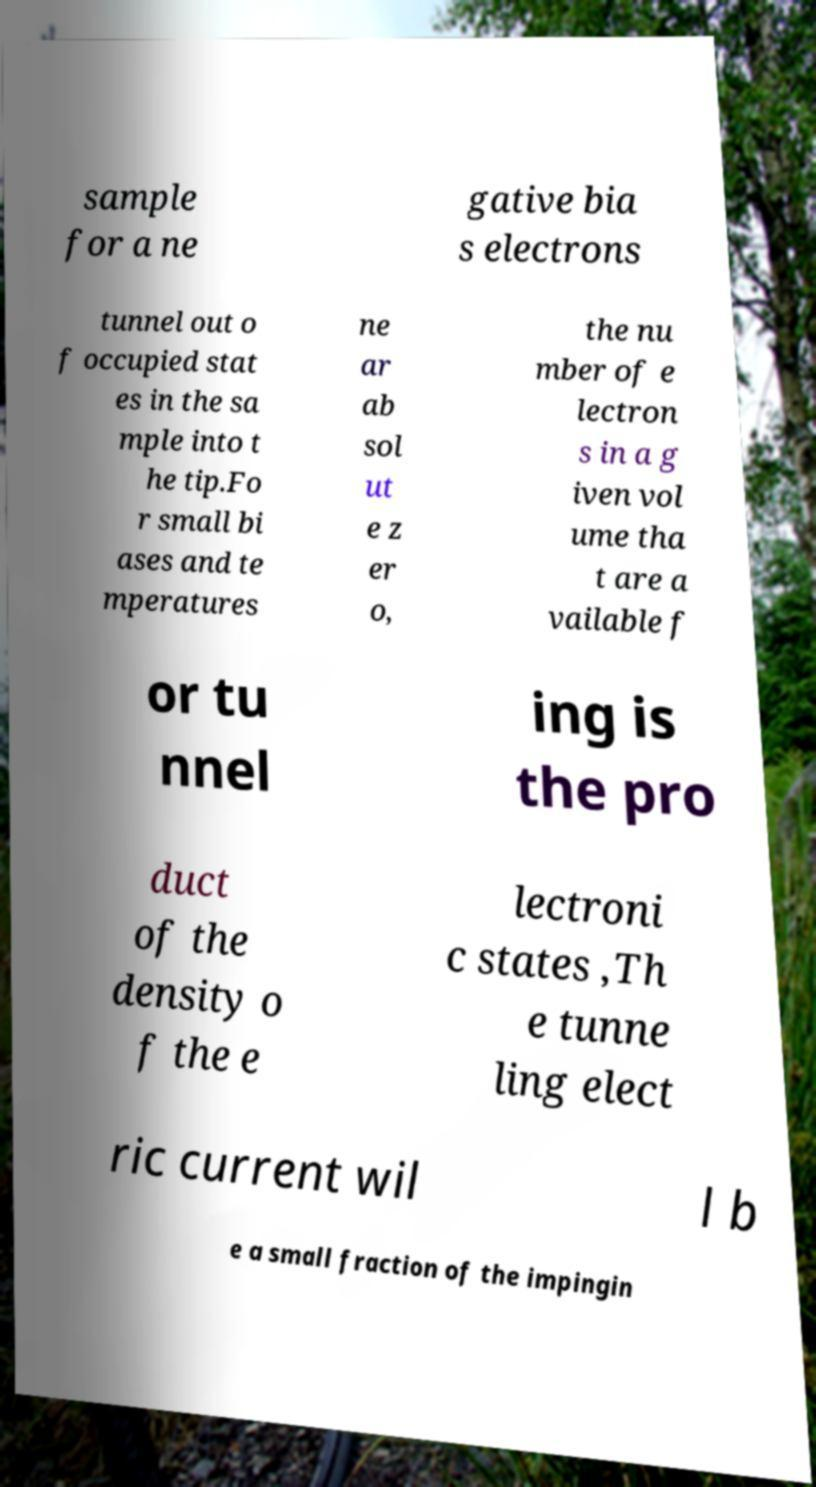Please read and relay the text visible in this image. What does it say? sample for a ne gative bia s electrons tunnel out o f occupied stat es in the sa mple into t he tip.Fo r small bi ases and te mperatures ne ar ab sol ut e z er o, the nu mber of e lectron s in a g iven vol ume tha t are a vailable f or tu nnel ing is the pro duct of the density o f the e lectroni c states ,Th e tunne ling elect ric current wil l b e a small fraction of the impingin 